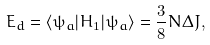Convert formula to latex. <formula><loc_0><loc_0><loc_500><loc_500>E _ { d } = \langle \psi _ { a } | H _ { 1 } | \psi _ { a } \rangle = { \frac { 3 } { 8 } } N \Delta J ,</formula> 